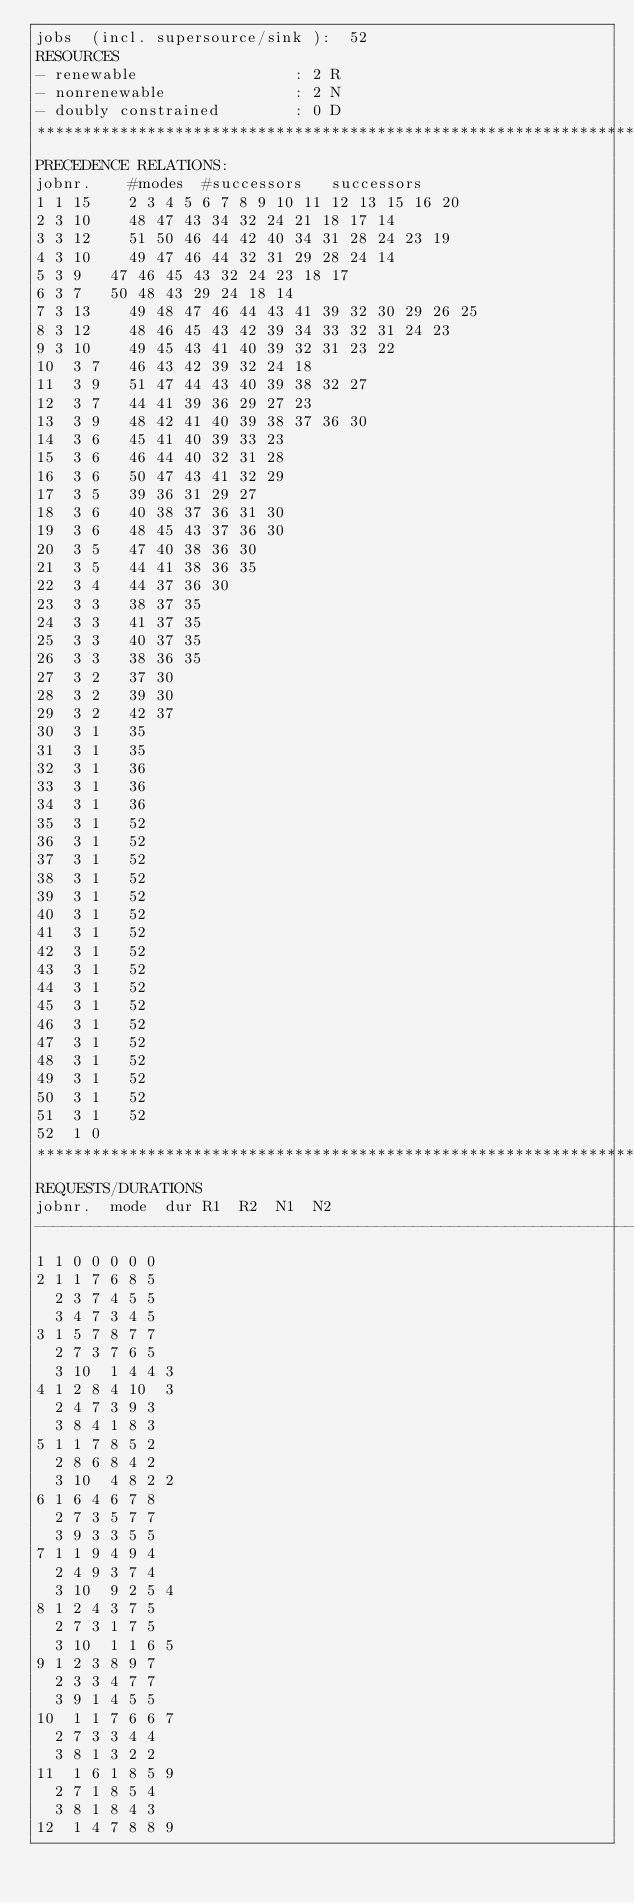Convert code to text. <code><loc_0><loc_0><loc_500><loc_500><_ObjectiveC_>jobs  (incl. supersource/sink ):	52
RESOURCES
- renewable                 : 2 R
- nonrenewable              : 2 N
- doubly constrained        : 0 D
************************************************************************
PRECEDENCE RELATIONS:
jobnr.    #modes  #successors   successors
1	1	15		2 3 4 5 6 7 8 9 10 11 12 13 15 16 20 
2	3	10		48 47 43 34 32 24 21 18 17 14 
3	3	12		51 50 46 44 42 40 34 31 28 24 23 19 
4	3	10		49 47 46 44 32 31 29 28 24 14 
5	3	9		47 46 45 43 32 24 23 18 17 
6	3	7		50 48 43 29 24 18 14 
7	3	13		49 48 47 46 44 43 41 39 32 30 29 26 25 
8	3	12		48 46 45 43 42 39 34 33 32 31 24 23 
9	3	10		49 45 43 41 40 39 32 31 23 22 
10	3	7		46 43 42 39 32 24 18 
11	3	9		51 47 44 43 40 39 38 32 27 
12	3	7		44 41 39 36 29 27 23 
13	3	9		48 42 41 40 39 38 37 36 30 
14	3	6		45 41 40 39 33 23 
15	3	6		46 44 40 32 31 28 
16	3	6		50 47 43 41 32 29 
17	3	5		39 36 31 29 27 
18	3	6		40 38 37 36 31 30 
19	3	6		48 45 43 37 36 30 
20	3	5		47 40 38 36 30 
21	3	5		44 41 38 36 35 
22	3	4		44 37 36 30 
23	3	3		38 37 35 
24	3	3		41 37 35 
25	3	3		40 37 35 
26	3	3		38 36 35 
27	3	2		37 30 
28	3	2		39 30 
29	3	2		42 37 
30	3	1		35 
31	3	1		35 
32	3	1		36 
33	3	1		36 
34	3	1		36 
35	3	1		52 
36	3	1		52 
37	3	1		52 
38	3	1		52 
39	3	1		52 
40	3	1		52 
41	3	1		52 
42	3	1		52 
43	3	1		52 
44	3	1		52 
45	3	1		52 
46	3	1		52 
47	3	1		52 
48	3	1		52 
49	3	1		52 
50	3	1		52 
51	3	1		52 
52	1	0		
************************************************************************
REQUESTS/DURATIONS
jobnr.	mode	dur	R1	R2	N1	N2	
------------------------------------------------------------------------
1	1	0	0	0	0	0	
2	1	1	7	6	8	5	
	2	3	7	4	5	5	
	3	4	7	3	4	5	
3	1	5	7	8	7	7	
	2	7	3	7	6	5	
	3	10	1	4	4	3	
4	1	2	8	4	10	3	
	2	4	7	3	9	3	
	3	8	4	1	8	3	
5	1	1	7	8	5	2	
	2	8	6	8	4	2	
	3	10	4	8	2	2	
6	1	6	4	6	7	8	
	2	7	3	5	7	7	
	3	9	3	3	5	5	
7	1	1	9	4	9	4	
	2	4	9	3	7	4	
	3	10	9	2	5	4	
8	1	2	4	3	7	5	
	2	7	3	1	7	5	
	3	10	1	1	6	5	
9	1	2	3	8	9	7	
	2	3	3	4	7	7	
	3	9	1	4	5	5	
10	1	1	7	6	6	7	
	2	7	3	3	4	4	
	3	8	1	3	2	2	
11	1	6	1	8	5	9	
	2	7	1	8	5	4	
	3	8	1	8	4	3	
12	1	4	7	8	8	9	</code> 